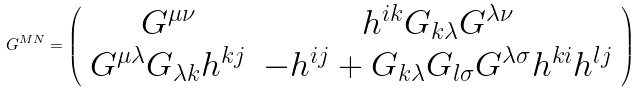<formula> <loc_0><loc_0><loc_500><loc_500>G ^ { M N } = \left ( \begin{array} { c c } G ^ { \mu \nu } & h ^ { i k } G _ { k \lambda } G ^ { \lambda \nu } \\ G ^ { \mu \lambda } G _ { \lambda k } h ^ { k j } & - h ^ { i j } + G _ { k \lambda } G _ { l \sigma } G ^ { \lambda \sigma } h ^ { k i } h ^ { l j } \end{array} \right )</formula> 